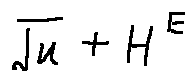Convert formula to latex. <formula><loc_0><loc_0><loc_500><loc_500>\sqrt { u } + H ^ { E }</formula> 